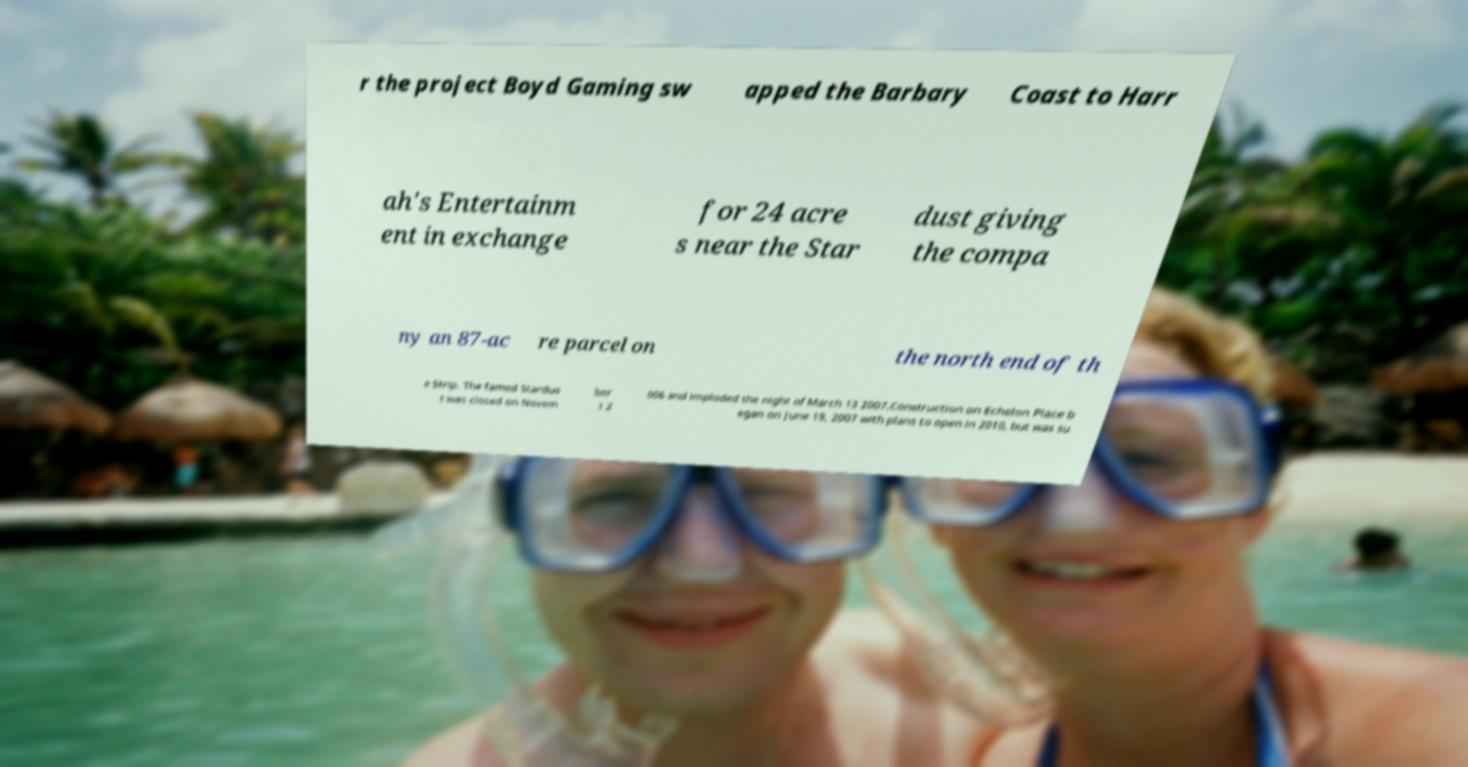What messages or text are displayed in this image? I need them in a readable, typed format. r the project Boyd Gaming sw apped the Barbary Coast to Harr ah's Entertainm ent in exchange for 24 acre s near the Star dust giving the compa ny an 87-ac re parcel on the north end of th e Strip. The famed Stardus t was closed on Novem ber 1 2 006 and imploded the night of March 13 2007.Construction on Echelon Place b egan on June 19, 2007 with plans to open in 2010, but was su 